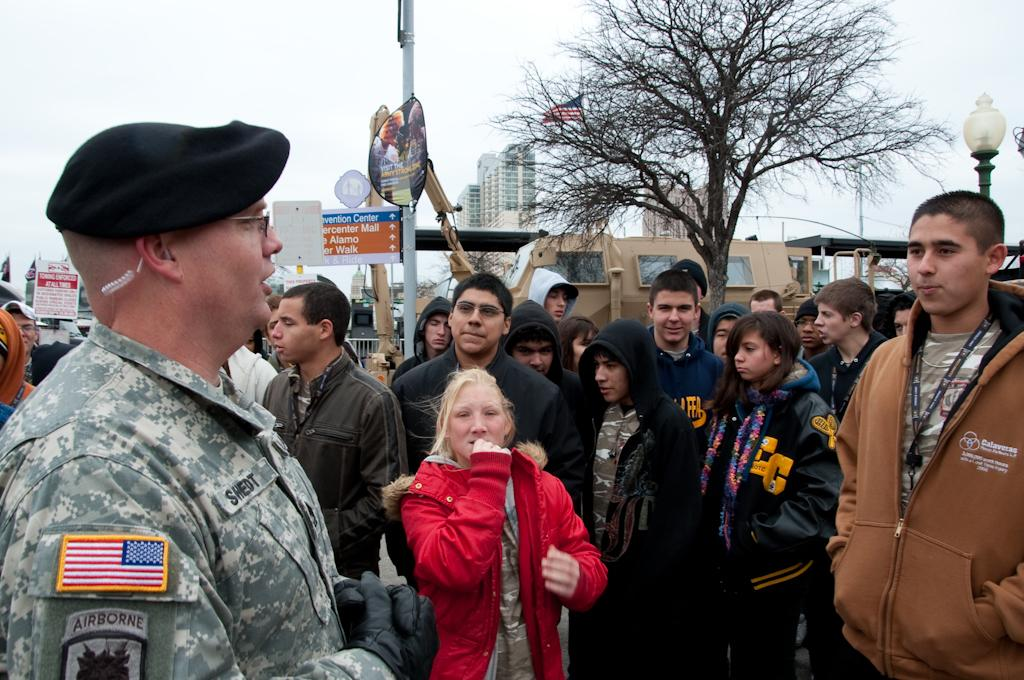What is happening in the image? There are persons standing in the image. What can be seen in the background of the image? There are trees, hoardings, boards on poles, a light pole, vehicles, buildings, and the sky visible in the background of the image. What type of soda is being shared between the persons in the image? There is no soda present in the image; it only shows persons standing and the background elements. 